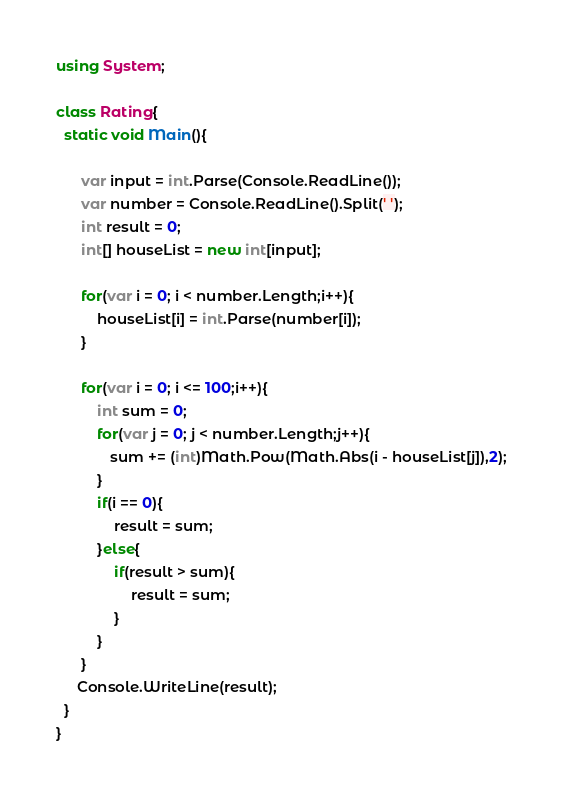Convert code to text. <code><loc_0><loc_0><loc_500><loc_500><_C#_>using System;

class Rating{
  static void Main(){
      
      var input = int.Parse(Console.ReadLine());
      var number = Console.ReadLine().Split(' ');
      int result = 0;
      int[] houseList = new int[input];
      
      for(var i = 0; i < number.Length;i++){
          houseList[i] = int.Parse(number[i]); 
      }
      
      for(var i = 0; i <= 100;i++){
          int sum = 0;
          for(var j = 0; j < number.Length;j++){
             sum += (int)Math.Pow(Math.Abs(i - houseList[j]),2); 
          }
          if(i == 0){
              result = sum;
          }else{
              if(result > sum){
                  result = sum;
              }
          }
      }
     Console.WriteLine(result);
  }
}</code> 